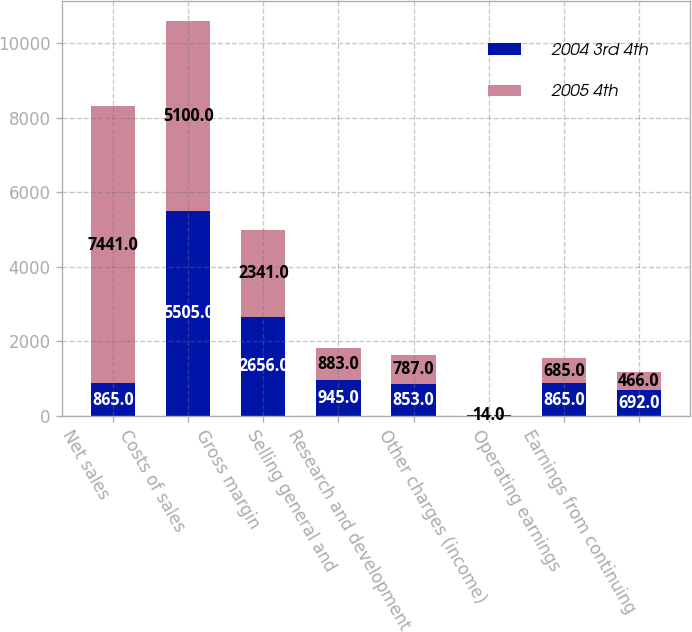<chart> <loc_0><loc_0><loc_500><loc_500><stacked_bar_chart><ecel><fcel>Net sales<fcel>Costs of sales<fcel>Gross margin<fcel>Selling general and<fcel>Research and development<fcel>Other charges (income)<fcel>Operating earnings<fcel>Earnings from continuing<nl><fcel>2004 3rd 4th<fcel>865<fcel>5505<fcel>2656<fcel>945<fcel>853<fcel>7<fcel>865<fcel>692<nl><fcel>2005 4th<fcel>7441<fcel>5100<fcel>2341<fcel>883<fcel>787<fcel>14<fcel>685<fcel>466<nl></chart> 